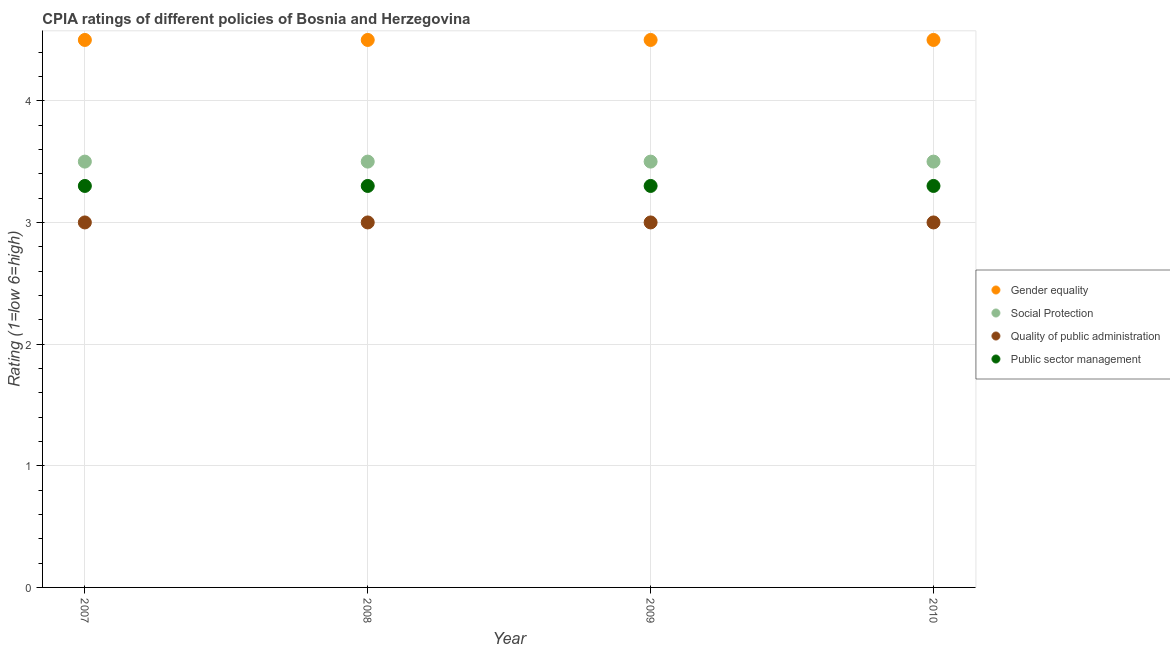How many different coloured dotlines are there?
Keep it short and to the point. 4. Is the number of dotlines equal to the number of legend labels?
Make the answer very short. Yes. What is the cpia rating of quality of public administration in 2008?
Provide a succinct answer. 3. Across all years, what is the minimum cpia rating of quality of public administration?
Your response must be concise. 3. In which year was the cpia rating of social protection maximum?
Give a very brief answer. 2007. In which year was the cpia rating of social protection minimum?
Your answer should be compact. 2007. What is the total cpia rating of gender equality in the graph?
Provide a short and direct response. 18. What is the difference between the cpia rating of social protection in 2007 and that in 2010?
Offer a terse response. 0. What is the difference between the cpia rating of social protection in 2007 and the cpia rating of public sector management in 2009?
Your response must be concise. 0.2. In the year 2007, what is the difference between the cpia rating of gender equality and cpia rating of public sector management?
Ensure brevity in your answer.  1.2. Is the difference between the cpia rating of social protection in 2008 and 2009 greater than the difference between the cpia rating of gender equality in 2008 and 2009?
Your response must be concise. No. What is the difference between the highest and the second highest cpia rating of social protection?
Your response must be concise. 0. In how many years, is the cpia rating of gender equality greater than the average cpia rating of gender equality taken over all years?
Make the answer very short. 0. Is the sum of the cpia rating of social protection in 2008 and 2010 greater than the maximum cpia rating of gender equality across all years?
Give a very brief answer. Yes. Is it the case that in every year, the sum of the cpia rating of social protection and cpia rating of gender equality is greater than the sum of cpia rating of quality of public administration and cpia rating of public sector management?
Ensure brevity in your answer.  No. Does the cpia rating of public sector management monotonically increase over the years?
Ensure brevity in your answer.  No. Is the cpia rating of social protection strictly greater than the cpia rating of quality of public administration over the years?
Your answer should be compact. Yes. Is the cpia rating of social protection strictly less than the cpia rating of public sector management over the years?
Your answer should be very brief. No. What is the difference between two consecutive major ticks on the Y-axis?
Offer a terse response. 1. Does the graph contain any zero values?
Your answer should be compact. No. How many legend labels are there?
Make the answer very short. 4. What is the title of the graph?
Make the answer very short. CPIA ratings of different policies of Bosnia and Herzegovina. Does "UNRWA" appear as one of the legend labels in the graph?
Ensure brevity in your answer.  No. What is the Rating (1=low 6=high) of Gender equality in 2008?
Your answer should be very brief. 4.5. What is the Rating (1=low 6=high) in Quality of public administration in 2008?
Your response must be concise. 3. What is the Rating (1=low 6=high) in Quality of public administration in 2009?
Keep it short and to the point. 3. What is the Rating (1=low 6=high) in Public sector management in 2009?
Provide a short and direct response. 3.3. What is the Rating (1=low 6=high) in Public sector management in 2010?
Provide a short and direct response. 3.3. Across all years, what is the maximum Rating (1=low 6=high) of Gender equality?
Ensure brevity in your answer.  4.5. Across all years, what is the maximum Rating (1=low 6=high) of Social Protection?
Provide a succinct answer. 3.5. Across all years, what is the maximum Rating (1=low 6=high) in Quality of public administration?
Your response must be concise. 3. Across all years, what is the minimum Rating (1=low 6=high) of Social Protection?
Make the answer very short. 3.5. Across all years, what is the minimum Rating (1=low 6=high) of Quality of public administration?
Your response must be concise. 3. What is the total Rating (1=low 6=high) of Gender equality in the graph?
Your answer should be very brief. 18. What is the difference between the Rating (1=low 6=high) of Quality of public administration in 2007 and that in 2009?
Offer a very short reply. 0. What is the difference between the Rating (1=low 6=high) of Public sector management in 2007 and that in 2010?
Keep it short and to the point. 0. What is the difference between the Rating (1=low 6=high) in Gender equality in 2008 and that in 2009?
Provide a succinct answer. 0. What is the difference between the Rating (1=low 6=high) of Social Protection in 2008 and that in 2009?
Offer a terse response. 0. What is the difference between the Rating (1=low 6=high) of Gender equality in 2008 and that in 2010?
Make the answer very short. 0. What is the difference between the Rating (1=low 6=high) of Quality of public administration in 2008 and that in 2010?
Your answer should be very brief. 0. What is the difference between the Rating (1=low 6=high) in Public sector management in 2008 and that in 2010?
Ensure brevity in your answer.  0. What is the difference between the Rating (1=low 6=high) in Gender equality in 2009 and that in 2010?
Keep it short and to the point. 0. What is the difference between the Rating (1=low 6=high) in Social Protection in 2009 and that in 2010?
Ensure brevity in your answer.  0. What is the difference between the Rating (1=low 6=high) in Public sector management in 2009 and that in 2010?
Keep it short and to the point. 0. What is the difference between the Rating (1=low 6=high) of Gender equality in 2007 and the Rating (1=low 6=high) of Quality of public administration in 2008?
Your response must be concise. 1.5. What is the difference between the Rating (1=low 6=high) in Social Protection in 2007 and the Rating (1=low 6=high) in Quality of public administration in 2008?
Ensure brevity in your answer.  0.5. What is the difference between the Rating (1=low 6=high) of Gender equality in 2007 and the Rating (1=low 6=high) of Quality of public administration in 2009?
Keep it short and to the point. 1.5. What is the difference between the Rating (1=low 6=high) of Social Protection in 2007 and the Rating (1=low 6=high) of Public sector management in 2009?
Give a very brief answer. 0.2. What is the difference between the Rating (1=low 6=high) in Quality of public administration in 2007 and the Rating (1=low 6=high) in Public sector management in 2009?
Your answer should be compact. -0.3. What is the difference between the Rating (1=low 6=high) of Gender equality in 2007 and the Rating (1=low 6=high) of Social Protection in 2010?
Give a very brief answer. 1. What is the difference between the Rating (1=low 6=high) of Gender equality in 2007 and the Rating (1=low 6=high) of Quality of public administration in 2010?
Offer a terse response. 1.5. What is the difference between the Rating (1=low 6=high) of Gender equality in 2007 and the Rating (1=low 6=high) of Public sector management in 2010?
Your response must be concise. 1.2. What is the difference between the Rating (1=low 6=high) in Quality of public administration in 2007 and the Rating (1=low 6=high) in Public sector management in 2010?
Your response must be concise. -0.3. What is the difference between the Rating (1=low 6=high) of Gender equality in 2008 and the Rating (1=low 6=high) of Quality of public administration in 2009?
Give a very brief answer. 1.5. What is the difference between the Rating (1=low 6=high) in Social Protection in 2008 and the Rating (1=low 6=high) in Public sector management in 2009?
Your answer should be very brief. 0.2. What is the difference between the Rating (1=low 6=high) in Gender equality in 2008 and the Rating (1=low 6=high) in Quality of public administration in 2010?
Make the answer very short. 1.5. What is the difference between the Rating (1=low 6=high) in Gender equality in 2009 and the Rating (1=low 6=high) in Social Protection in 2010?
Make the answer very short. 1. What is the difference between the Rating (1=low 6=high) of Social Protection in 2009 and the Rating (1=low 6=high) of Public sector management in 2010?
Keep it short and to the point. 0.2. What is the difference between the Rating (1=low 6=high) in Quality of public administration in 2009 and the Rating (1=low 6=high) in Public sector management in 2010?
Your answer should be compact. -0.3. What is the average Rating (1=low 6=high) in Public sector management per year?
Offer a terse response. 3.3. In the year 2007, what is the difference between the Rating (1=low 6=high) of Gender equality and Rating (1=low 6=high) of Quality of public administration?
Offer a terse response. 1.5. In the year 2007, what is the difference between the Rating (1=low 6=high) of Social Protection and Rating (1=low 6=high) of Quality of public administration?
Provide a short and direct response. 0.5. In the year 2007, what is the difference between the Rating (1=low 6=high) of Quality of public administration and Rating (1=low 6=high) of Public sector management?
Offer a terse response. -0.3. In the year 2008, what is the difference between the Rating (1=low 6=high) of Gender equality and Rating (1=low 6=high) of Public sector management?
Ensure brevity in your answer.  1.2. In the year 2008, what is the difference between the Rating (1=low 6=high) of Social Protection and Rating (1=low 6=high) of Quality of public administration?
Make the answer very short. 0.5. In the year 2008, what is the difference between the Rating (1=low 6=high) in Social Protection and Rating (1=low 6=high) in Public sector management?
Keep it short and to the point. 0.2. In the year 2008, what is the difference between the Rating (1=low 6=high) in Quality of public administration and Rating (1=low 6=high) in Public sector management?
Offer a terse response. -0.3. In the year 2009, what is the difference between the Rating (1=low 6=high) of Gender equality and Rating (1=low 6=high) of Quality of public administration?
Offer a terse response. 1.5. In the year 2009, what is the difference between the Rating (1=low 6=high) of Gender equality and Rating (1=low 6=high) of Public sector management?
Give a very brief answer. 1.2. In the year 2009, what is the difference between the Rating (1=low 6=high) in Social Protection and Rating (1=low 6=high) in Public sector management?
Offer a very short reply. 0.2. In the year 2009, what is the difference between the Rating (1=low 6=high) of Quality of public administration and Rating (1=low 6=high) of Public sector management?
Your answer should be compact. -0.3. In the year 2010, what is the difference between the Rating (1=low 6=high) of Quality of public administration and Rating (1=low 6=high) of Public sector management?
Make the answer very short. -0.3. What is the ratio of the Rating (1=low 6=high) of Social Protection in 2007 to that in 2008?
Provide a short and direct response. 1. What is the ratio of the Rating (1=low 6=high) of Public sector management in 2007 to that in 2008?
Your answer should be compact. 1. What is the ratio of the Rating (1=low 6=high) in Gender equality in 2007 to that in 2009?
Your response must be concise. 1. What is the ratio of the Rating (1=low 6=high) in Social Protection in 2007 to that in 2009?
Offer a terse response. 1. What is the ratio of the Rating (1=low 6=high) in Quality of public administration in 2007 to that in 2009?
Offer a very short reply. 1. What is the ratio of the Rating (1=low 6=high) in Public sector management in 2007 to that in 2009?
Ensure brevity in your answer.  1. What is the ratio of the Rating (1=low 6=high) in Gender equality in 2007 to that in 2010?
Your response must be concise. 1. What is the ratio of the Rating (1=low 6=high) of Social Protection in 2007 to that in 2010?
Your answer should be very brief. 1. What is the ratio of the Rating (1=low 6=high) of Quality of public administration in 2007 to that in 2010?
Your answer should be very brief. 1. What is the ratio of the Rating (1=low 6=high) of Public sector management in 2007 to that in 2010?
Your answer should be compact. 1. What is the ratio of the Rating (1=low 6=high) of Gender equality in 2008 to that in 2009?
Make the answer very short. 1. What is the ratio of the Rating (1=low 6=high) in Public sector management in 2008 to that in 2010?
Give a very brief answer. 1. What is the ratio of the Rating (1=low 6=high) in Social Protection in 2009 to that in 2010?
Ensure brevity in your answer.  1. What is the ratio of the Rating (1=low 6=high) of Public sector management in 2009 to that in 2010?
Provide a short and direct response. 1. What is the difference between the highest and the second highest Rating (1=low 6=high) of Public sector management?
Your answer should be compact. 0. What is the difference between the highest and the lowest Rating (1=low 6=high) of Quality of public administration?
Give a very brief answer. 0. What is the difference between the highest and the lowest Rating (1=low 6=high) of Public sector management?
Make the answer very short. 0. 